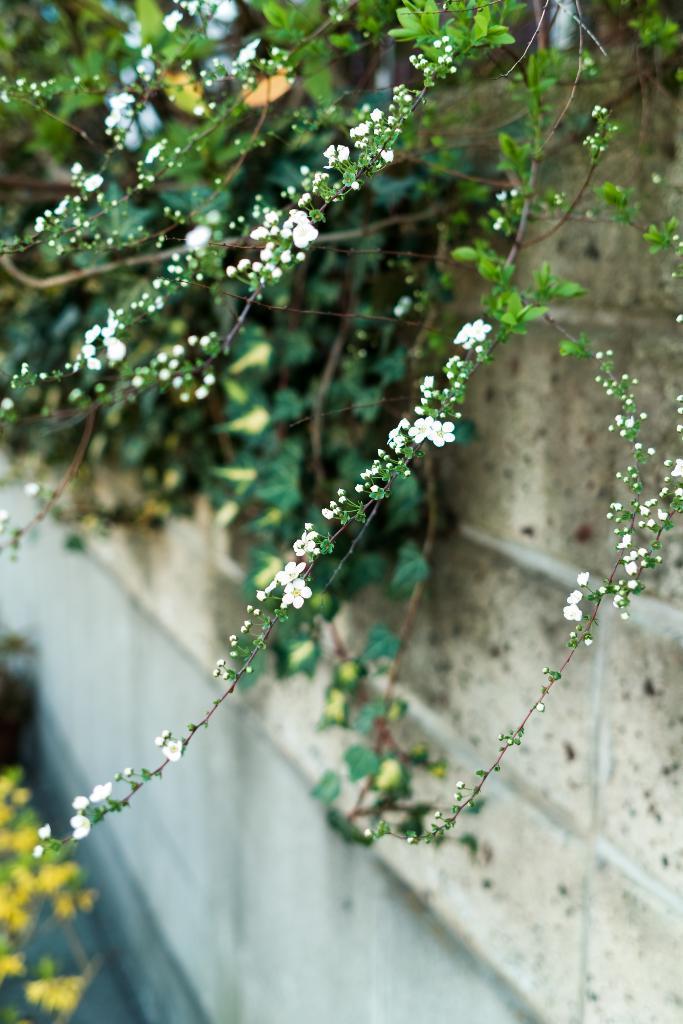Could you give a brief overview of what you see in this image? In this image I can see few flowers in white and yellow color, few plants in green color and the wall is in cream color. 